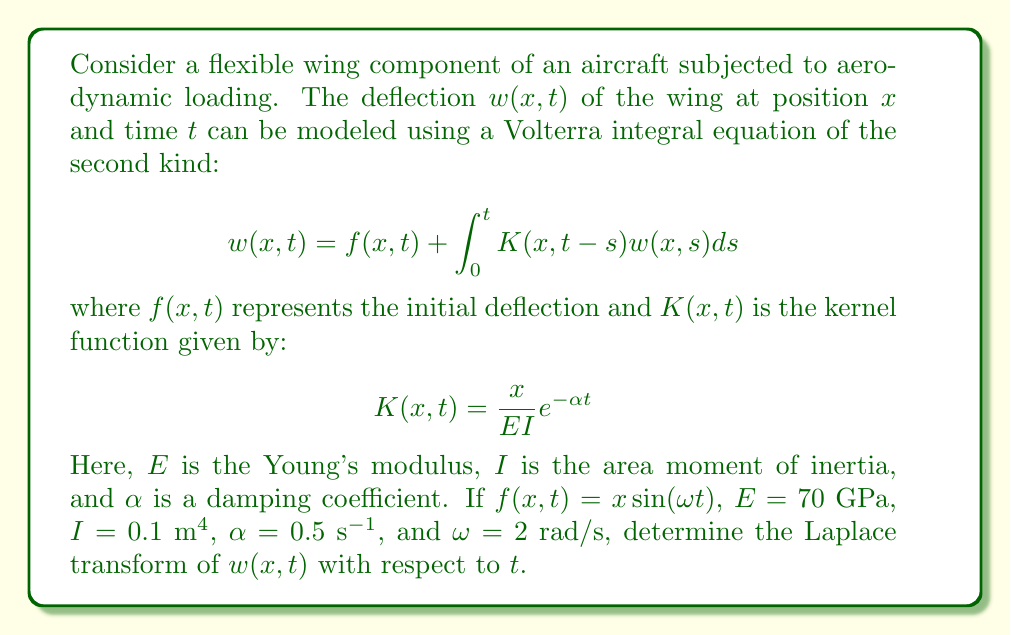What is the answer to this math problem? To solve this problem, we'll follow these steps:

1) First, let's take the Laplace transform of both sides of the Volterra integral equation with respect to $t$. Let $W(x,s)$ be the Laplace transform of $w(x,t)$:

   $$\mathcal{L}\{w(x,t)\} = \mathcal{L}\{f(x,t)\} + \mathcal{L}\{\int_0^t K(x,t-s)w(x,s)ds\}$$

2) The Laplace transform of $f(x,t) = x\sin(\omega t)$ is:

   $$\mathcal{L}\{f(x,t)\} = x\frac{\omega}{s^2 + \omega^2}$$

3) For the integral term, we can use the convolution theorem:

   $$\mathcal{L}\{\int_0^t K(x,t-s)w(x,s)ds\} = \mathcal{L}\{K(x,t)\} \cdot W(x,s)$$

4) Now, let's find the Laplace transform of $K(x,t)$:

   $$\mathcal{L}\{K(x,t)\} = \mathcal{L}\{\frac{x}{EI}e^{-\alpha t}\} = \frac{x}{EI} \cdot \frac{1}{s + \alpha}$$

5) Substituting these results into the Laplace-transformed equation:

   $$W(x,s) = x\frac{\omega}{s^2 + \omega^2} + \frac{x}{EI} \cdot \frac{1}{s + \alpha} \cdot W(x,s)$$

6) Rearranging the equation:

   $$W(x,s) - \frac{x}{EI} \cdot \frac{1}{s + \alpha} \cdot W(x,s) = x\frac{\omega}{s^2 + \omega^2}$$

   $$W(x,s) \left(1 - \frac{x}{EI} \cdot \frac{1}{s + \alpha}\right) = x\frac{\omega}{s^2 + \omega^2}$$

7) Solving for $W(x,s)$:

   $$W(x,s) = \frac{x\frac{\omega}{s^2 + \omega^2}}{1 - \frac{x}{EI} \cdot \frac{1}{s + \alpha}}$$

8) Substituting the given values ($E = 70$ GPa, $I = 0.1$ m⁴, $\alpha = 0.5$ s⁻¹, $\omega = 2$ rad/s):

   $$W(x,s) = \frac{x\frac{2}{s^2 + 4}}{1 - \frac{x}{7 \times 10^9 \times 0.1} \cdot \frac{1}{s + 0.5}}$$

This is the final expression for the Laplace transform of $w(x,t)$.
Answer: $$W(x,s) = \frac{x\frac{2}{s^2 + 4}}{1 - \frac{x}{7 \times 10^8} \cdot \frac{1}{s + 0.5}}$$ 